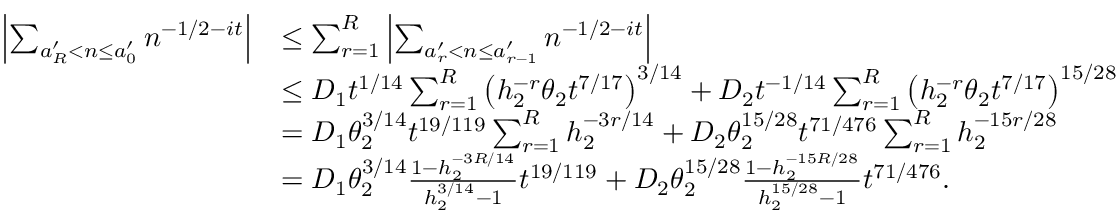Convert formula to latex. <formula><loc_0><loc_0><loc_500><loc_500>\begin{array} { r l } { \left | \sum _ { a _ { R } ^ { \prime } < n \leq a _ { 0 } ^ { \prime } } n ^ { - 1 / 2 - i t } \right | } & { \leq \sum _ { r = 1 } ^ { R } \left | \sum _ { a _ { r } ^ { \prime } < n \leq a _ { r - 1 } ^ { \prime } } n ^ { - 1 / 2 - i t } \right | } \\ & { \leq D _ { 1 } t ^ { 1 / 1 4 } \sum _ { r = 1 } ^ { R } \left ( h _ { 2 } ^ { - r } \theta _ { 2 } t ^ { 7 / 1 7 } \right ) ^ { 3 / 1 4 } + D _ { 2 } t ^ { - 1 / 1 4 } \sum _ { r = 1 } ^ { R } \left ( h _ { 2 } ^ { - r } \theta _ { 2 } t ^ { 7 / 1 7 } \right ) ^ { 1 5 / 2 8 } } \\ & { = D _ { 1 } \theta _ { 2 } ^ { 3 / 1 4 } t ^ { 1 9 / 1 1 9 } \sum _ { r = 1 } ^ { R } h _ { 2 } ^ { - 3 r / 1 4 } + D _ { 2 } \theta _ { 2 } ^ { 1 5 / 2 8 } t ^ { 7 1 / 4 7 6 } \sum _ { r = 1 } ^ { R } h _ { 2 } ^ { - 1 5 r / 2 8 } } \\ & { = D _ { 1 } \theta _ { 2 } ^ { 3 / 1 4 } \frac { 1 - h _ { 2 } ^ { - 3 R / 1 4 } } { h _ { 2 } ^ { 3 / 1 4 } - 1 } t ^ { 1 9 / 1 1 9 } + D _ { 2 } \theta _ { 2 } ^ { 1 5 / 2 8 } \frac { 1 - h _ { 2 } ^ { - 1 5 R / 2 8 } } { h _ { 2 } ^ { 1 5 / 2 8 } - 1 } t ^ { 7 1 / 4 7 6 } . } \end{array}</formula> 